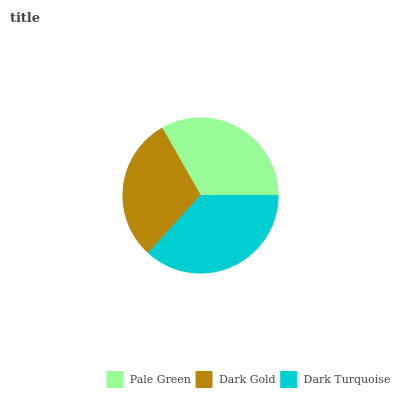Is Dark Gold the minimum?
Answer yes or no. Yes. Is Dark Turquoise the maximum?
Answer yes or no. Yes. Is Dark Turquoise the minimum?
Answer yes or no. No. Is Dark Gold the maximum?
Answer yes or no. No. Is Dark Turquoise greater than Dark Gold?
Answer yes or no. Yes. Is Dark Gold less than Dark Turquoise?
Answer yes or no. Yes. Is Dark Gold greater than Dark Turquoise?
Answer yes or no. No. Is Dark Turquoise less than Dark Gold?
Answer yes or no. No. Is Pale Green the high median?
Answer yes or no. Yes. Is Pale Green the low median?
Answer yes or no. Yes. Is Dark Gold the high median?
Answer yes or no. No. Is Dark Gold the low median?
Answer yes or no. No. 